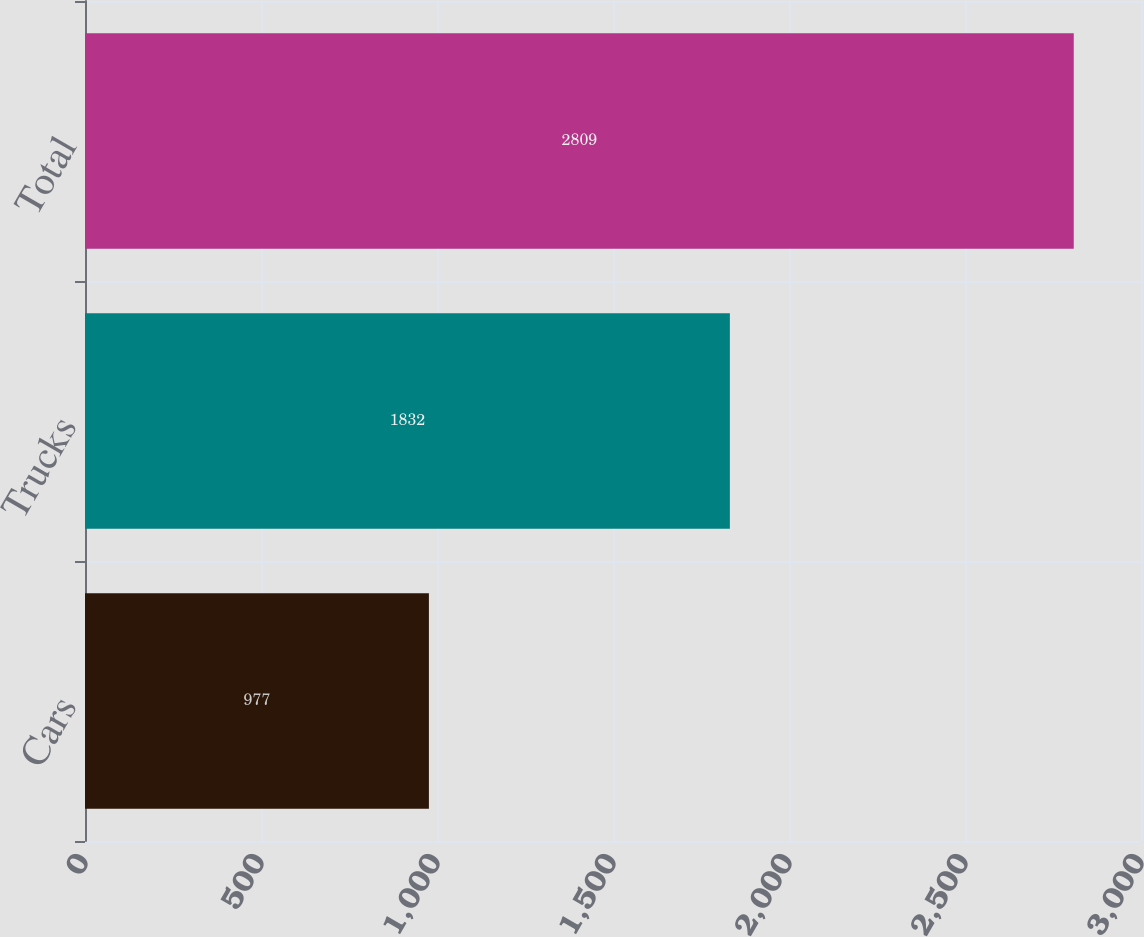Convert chart to OTSL. <chart><loc_0><loc_0><loc_500><loc_500><bar_chart><fcel>Cars<fcel>Trucks<fcel>Total<nl><fcel>977<fcel>1832<fcel>2809<nl></chart> 